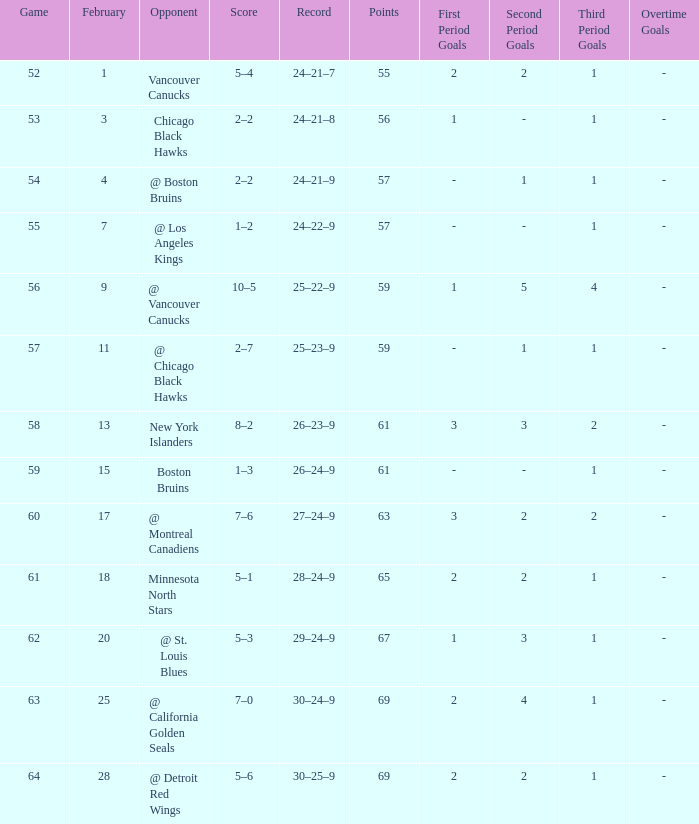Which opponent has a game larger than 61, february smaller than 28, and fewer points than 69? @ St. Louis Blues. 